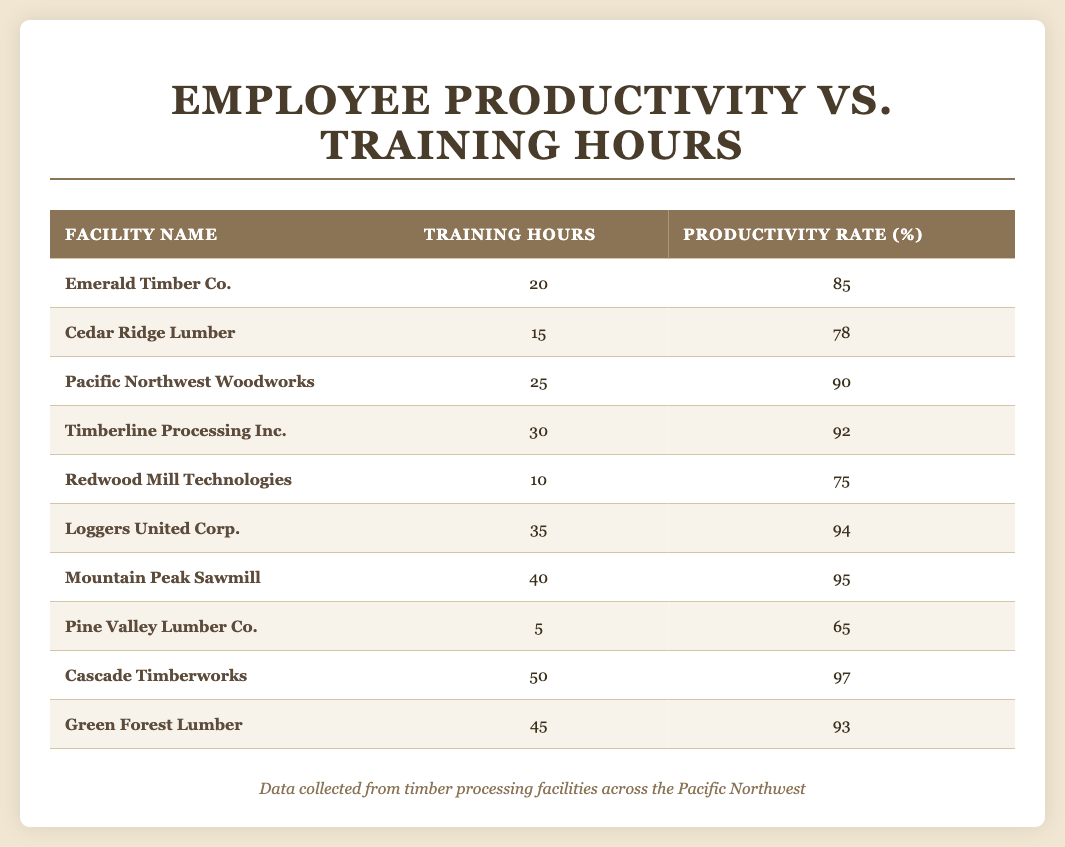What is the productivity rate of Cascade Timberworks? The productivity rate for Cascade Timberworks is listed directly in the table under the column "Productivity Rate (%)." The value beside Cascade Timberworks is 97.
Answer: 97 How many training hours did the facility with the highest productivity rate have? The table shows that Cascade Timberworks has the highest productivity rate at 97%, and it also lists 50 training hours associated with that productivity rate.
Answer: 50 Which facility had the lowest productivity rate and how many training hours did it undergo? Checking the column for productivity rates, Pine Valley Lumber Co. has the lowest productivity rate listed at 65%. The corresponding training hours for this facility are 5 according to the table.
Answer: 5 What is the average productivity rate of all facilities listed? To find the average productivity rate, we add up all the rates: 85 + 78 + 90 + 92 + 75 + 94 + 95 + 65 + 97 + 93 =  92. The total count of facilities is 10, so we divide 920 by 10: 920/10 = 92.
Answer: 92 Is it true that facilities with more than 30 training hours always have a productivity rate above 90? We need to check for facilities with more than 30 training hours and verify their productivity rates. Facilities fitting the criteria: Timberline Processing Inc. (92), Loggers United Corp. (94), Mountain Peak Sawmill (95), and Cascade Timberworks (97). All these rates exceed 90, confirming that the statement is true.
Answer: Yes How does the training hours of the facility with the highest productivity rate compare to the facility with the lowest? Cascade Timberworks has 50 training hours while Pine Valley Lumber Co. has 5 training hours. The difference is calculated as 50 - 5 = 45, indicating Cascade Timberworks had 45 more training hours than the lowest productivity facility.
Answer: 45 Which facility had the second highest training hours, and what was its productivity rate? According to the table, Cascade Timberworks has the highest training hours at 50. The second highest, Green Forest Lumber, has 45 training hours listed and a productivity rate of 93%.
Answer: 93 What percentage of facilities had a productivity rate over 90? There are 4 facilities with productivity rates over 90: Timberline Processing Inc., Loggers United Corp., Mountain Peak Sawmill, and Cascade Timberworks out of a total of 10 facilities. (4/10)*100 = 40%.
Answer: 40% 